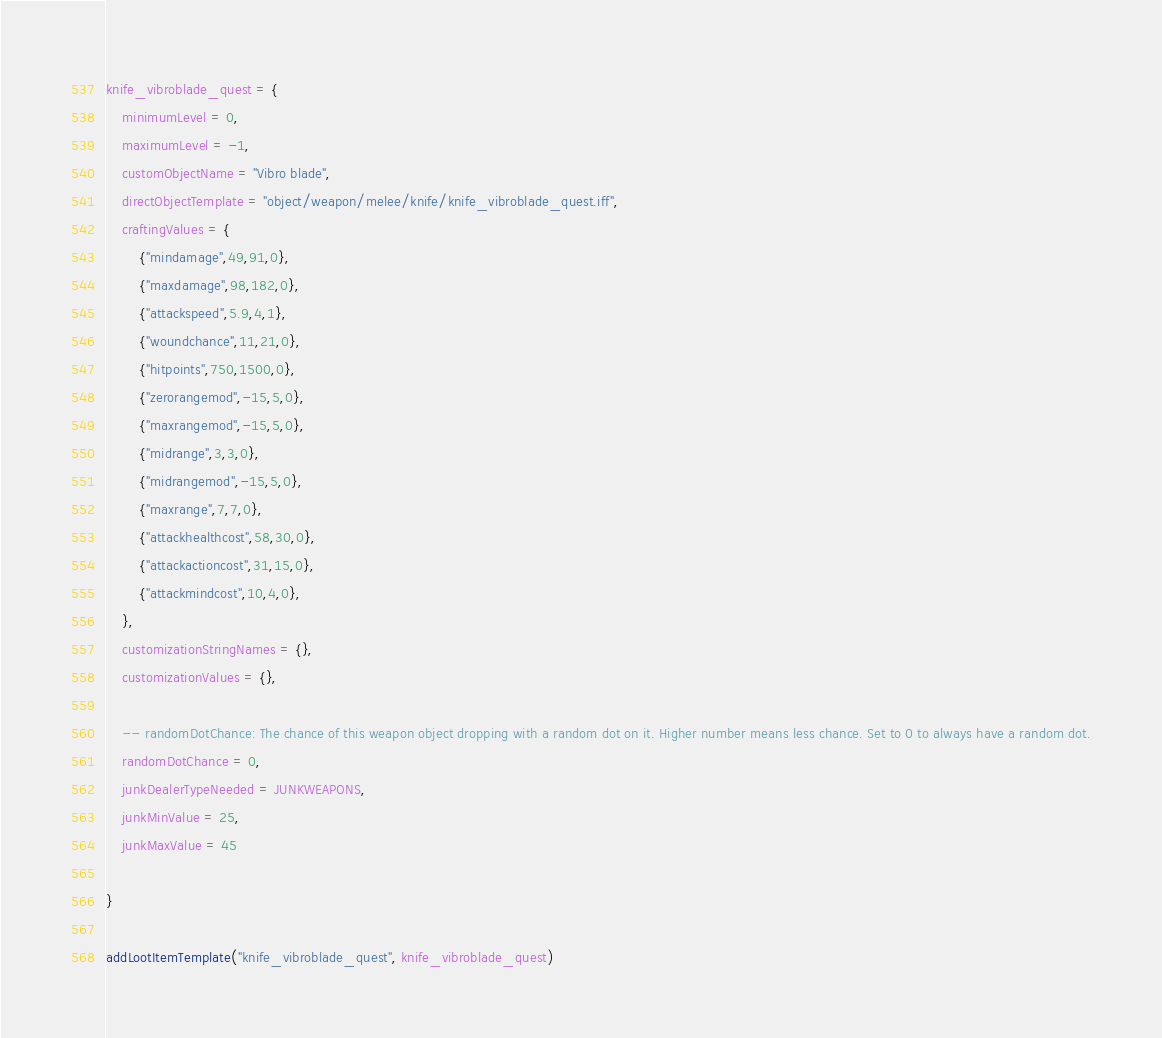<code> <loc_0><loc_0><loc_500><loc_500><_Lua_>knife_vibroblade_quest = {
	minimumLevel = 0,
	maximumLevel = -1,
	customObjectName = "Vibro blade",
	directObjectTemplate = "object/weapon/melee/knife/knife_vibroblade_quest.iff",
	craftingValues = {
		{"mindamage",49,91,0},
		{"maxdamage",98,182,0},
		{"attackspeed",5.9,4,1},
		{"woundchance",11,21,0},
		{"hitpoints",750,1500,0},
		{"zerorangemod",-15,5,0},
		{"maxrangemod",-15,5,0},
		{"midrange",3,3,0},
		{"midrangemod",-15,5,0},
		{"maxrange",7,7,0},
		{"attackhealthcost",58,30,0},
		{"attackactioncost",31,15,0},
		{"attackmindcost",10,4,0},
	},
	customizationStringNames = {},
	customizationValues = {},

	-- randomDotChance: The chance of this weapon object dropping with a random dot on it. Higher number means less chance. Set to 0 to always have a random dot.
	randomDotChance = 0,
	junkDealerTypeNeeded = JUNKWEAPONS,
	junkMinValue = 25,
	junkMaxValue = 45

}

addLootItemTemplate("knife_vibroblade_quest", knife_vibroblade_quest)
</code> 